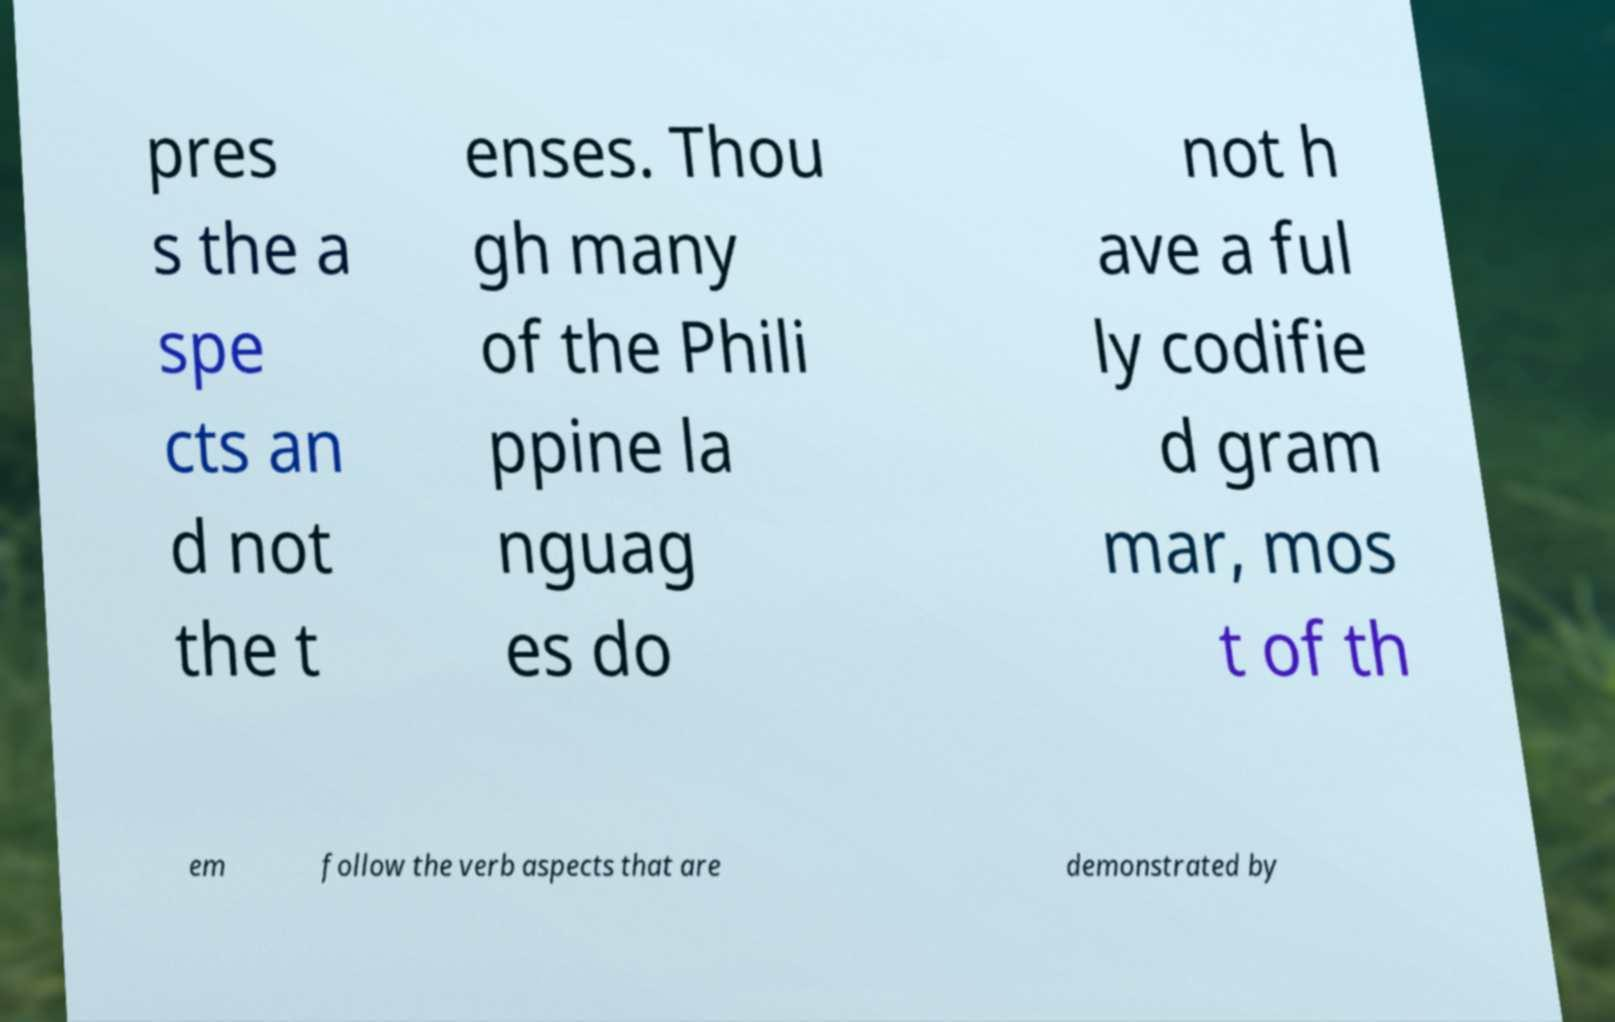For documentation purposes, I need the text within this image transcribed. Could you provide that? pres s the a spe cts an d not the t enses. Thou gh many of the Phili ppine la nguag es do not h ave a ful ly codifie d gram mar, mos t of th em follow the verb aspects that are demonstrated by 